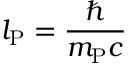<formula> <loc_0><loc_0><loc_500><loc_500>l _ { P } = { \frac { } { m _ { P } c } }</formula> 